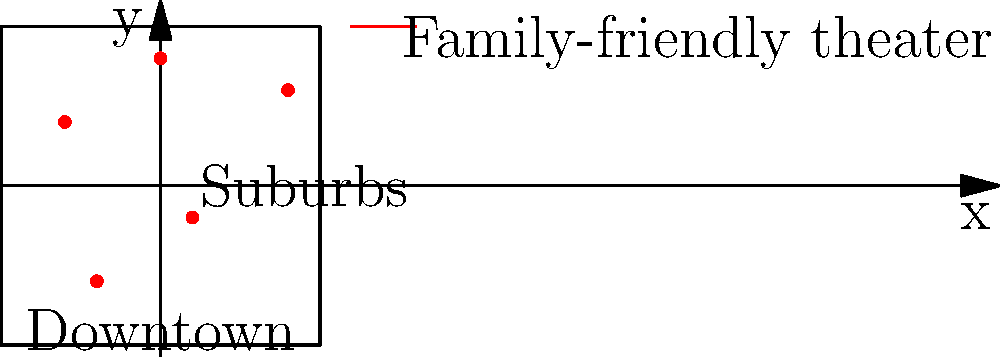The map shows the distribution of family-friendly theaters in a city. If we assume that the population density follows a normal distribution centered at the origin (0,0) with standard deviation $\sigma = 2$, what percentage of the population lives within 1 unit distance of at least one theater? (Assume the city limits extend infinitely in all directions.) To solve this problem, we'll follow these steps:

1) First, we need to identify the theaters that are within 1 unit of the origin. From the map, we can see that only one theater, located at approximately (0,4), meets this criterion.

2) The area within 1 unit of this theater can be represented by a circle with radius 1 centered at (0,4).

3) To calculate the percentage of the population within this area, we need to integrate the 2D normal distribution over this circle.

4) The 2D normal distribution centered at (0,0) with standard deviation $\sigma$ is given by:

   $f(x,y) = \frac{1}{2\pi\sigma^2} e^{-\frac{x^2+y^2}{2\sigma^2}}$

5) We need to integrate this over the circle $(x-0)^2 + (y-4)^2 \leq 1$

6) This integration is complex and typically requires numerical methods. However, we can approximate it using the fact that the circle is small compared to the overall distribution.

7) The area of the circle is $\pi r^2 = \pi (1)^2 = \pi$

8) The value of the density function at the center of the circle (0,4) is:

   $f(0,4) = \frac{1}{2\pi(2)^2} e^{-\frac{0^2+4^2}{2(2)^2}} = \frac{1}{8\pi} e^{-2} \approx 0.0054$

9) Approximating the integral by multiplying this value by the area of the circle:

   $\pi * 0.0054 \approx 0.017$ or about 1.7%

This is an approximation, but it gives us a reasonable estimate given the complexity of the exact calculation.
Answer: Approximately 1.7% 